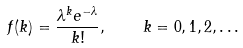<formula> <loc_0><loc_0><loc_500><loc_500>f ( k ) = \frac { \lambda ^ { k } e ^ { - \lambda } } { k ! } , \quad k = 0 , 1 , 2 , \dots</formula> 